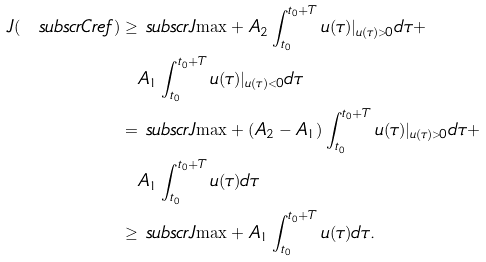<formula> <loc_0><loc_0><loc_500><loc_500>J ( \ s u b s c r { C } { r e f } ) \geq & \ s u b s c r { J } { \max } + A _ { 2 } \int _ { t _ { 0 } } ^ { t _ { 0 } + T } u ( \tau ) | _ { u ( \tau ) > 0 } d \tau + \\ & A _ { 1 } \int _ { t _ { 0 } } ^ { t _ { 0 } + T } u ( \tau ) | _ { u ( \tau ) < 0 } d \tau \\ = & \ s u b s c r { J } { \max } + ( A _ { 2 } - A _ { 1 } ) \int _ { t _ { 0 } } ^ { t _ { 0 } + T } u ( \tau ) | _ { u ( \tau ) > 0 } d \tau + \\ & A _ { 1 } \int _ { t _ { 0 } } ^ { t _ { 0 } + T } u ( \tau ) d \tau \\ \geq & \ s u b s c r { J } { \max } + A _ { 1 } \int _ { t _ { 0 } } ^ { t _ { 0 } + T } u ( \tau ) d \tau .</formula> 